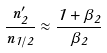<formula> <loc_0><loc_0><loc_500><loc_500>\frac { n _ { 2 } ^ { \prime } } { n _ { 1 / 2 } } \approx \frac { 1 + \beta _ { 2 } } { \beta _ { 2 } }</formula> 